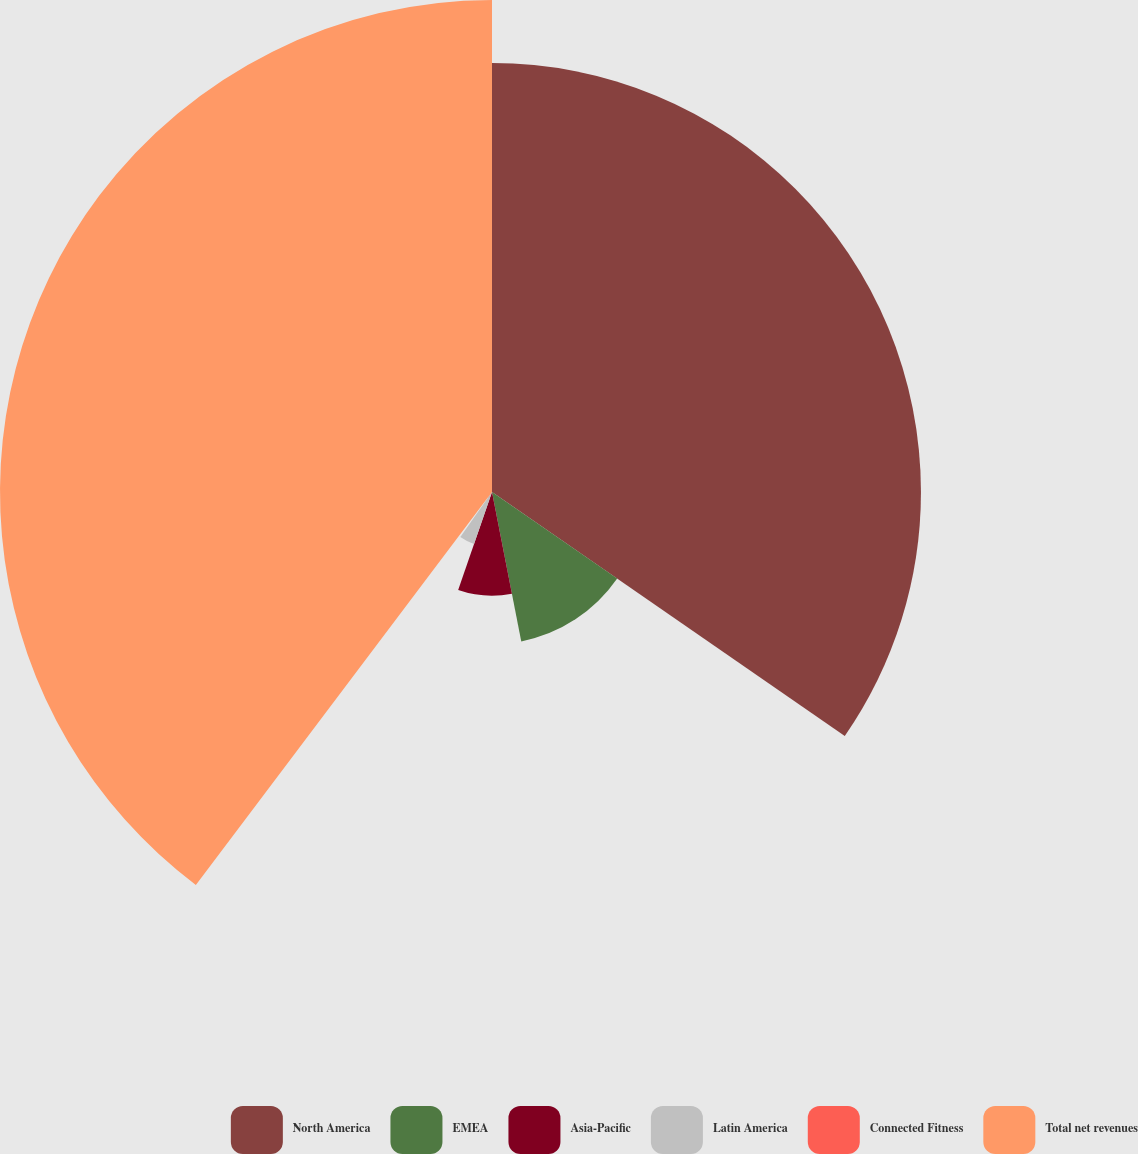Convert chart. <chart><loc_0><loc_0><loc_500><loc_500><pie_chart><fcel>North America<fcel>EMEA<fcel>Asia-Pacific<fcel>Latin America<fcel>Connected Fitness<fcel>Total net revenues<nl><fcel>34.63%<fcel>12.29%<fcel>8.37%<fcel>4.45%<fcel>0.54%<fcel>39.72%<nl></chart> 